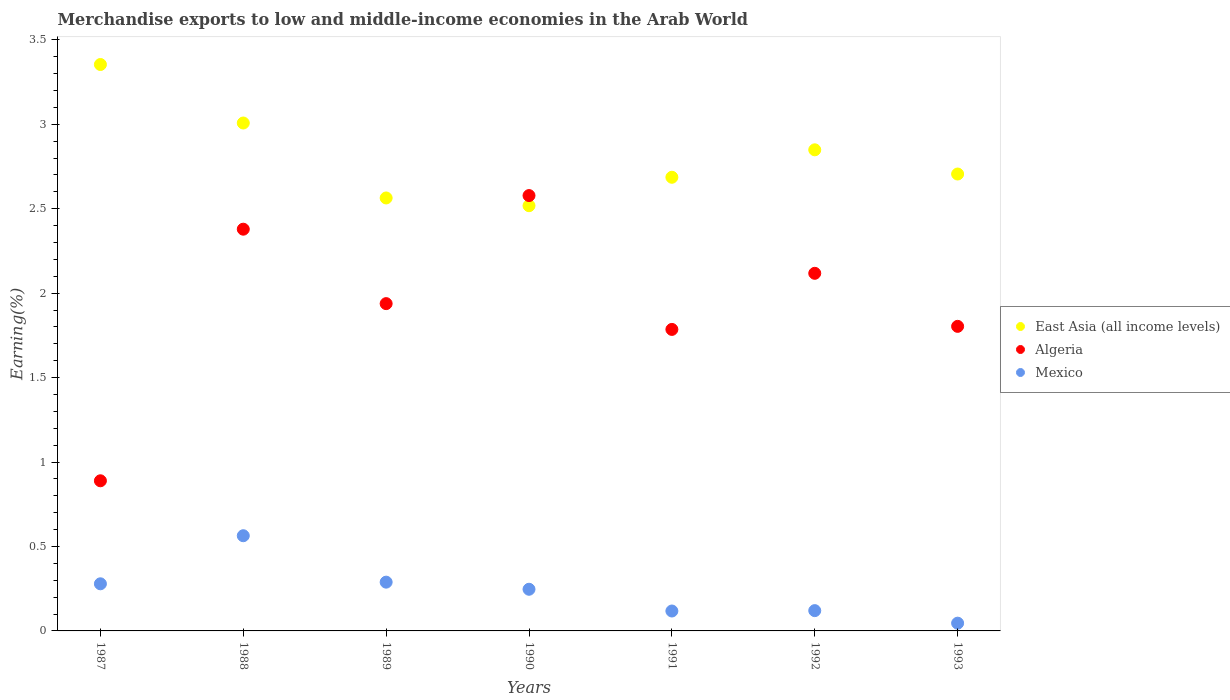How many different coloured dotlines are there?
Keep it short and to the point. 3. What is the percentage of amount earned from merchandise exports in Algeria in 1988?
Keep it short and to the point. 2.38. Across all years, what is the maximum percentage of amount earned from merchandise exports in East Asia (all income levels)?
Your answer should be compact. 3.35. Across all years, what is the minimum percentage of amount earned from merchandise exports in Algeria?
Provide a short and direct response. 0.89. In which year was the percentage of amount earned from merchandise exports in Algeria maximum?
Provide a succinct answer. 1990. In which year was the percentage of amount earned from merchandise exports in East Asia (all income levels) minimum?
Ensure brevity in your answer.  1990. What is the total percentage of amount earned from merchandise exports in Algeria in the graph?
Provide a short and direct response. 13.49. What is the difference between the percentage of amount earned from merchandise exports in East Asia (all income levels) in 1987 and that in 1990?
Your answer should be compact. 0.84. What is the difference between the percentage of amount earned from merchandise exports in Algeria in 1993 and the percentage of amount earned from merchandise exports in Mexico in 1990?
Keep it short and to the point. 1.56. What is the average percentage of amount earned from merchandise exports in Mexico per year?
Provide a short and direct response. 0.24. In the year 1992, what is the difference between the percentage of amount earned from merchandise exports in Algeria and percentage of amount earned from merchandise exports in East Asia (all income levels)?
Your answer should be very brief. -0.73. In how many years, is the percentage of amount earned from merchandise exports in East Asia (all income levels) greater than 1.6 %?
Your answer should be very brief. 7. What is the ratio of the percentage of amount earned from merchandise exports in Algeria in 1991 to that in 1992?
Keep it short and to the point. 0.84. Is the percentage of amount earned from merchandise exports in Mexico in 1988 less than that in 1991?
Your answer should be compact. No. What is the difference between the highest and the second highest percentage of amount earned from merchandise exports in Mexico?
Your answer should be compact. 0.27. What is the difference between the highest and the lowest percentage of amount earned from merchandise exports in Algeria?
Your answer should be compact. 1.69. In how many years, is the percentage of amount earned from merchandise exports in East Asia (all income levels) greater than the average percentage of amount earned from merchandise exports in East Asia (all income levels) taken over all years?
Ensure brevity in your answer.  3. Does the percentage of amount earned from merchandise exports in Mexico monotonically increase over the years?
Give a very brief answer. No. Is the percentage of amount earned from merchandise exports in East Asia (all income levels) strictly greater than the percentage of amount earned from merchandise exports in Algeria over the years?
Offer a very short reply. No. Is the percentage of amount earned from merchandise exports in Algeria strictly less than the percentage of amount earned from merchandise exports in Mexico over the years?
Make the answer very short. No. How many years are there in the graph?
Ensure brevity in your answer.  7. What is the difference between two consecutive major ticks on the Y-axis?
Provide a short and direct response. 0.5. Are the values on the major ticks of Y-axis written in scientific E-notation?
Offer a very short reply. No. How are the legend labels stacked?
Your answer should be compact. Vertical. What is the title of the graph?
Provide a short and direct response. Merchandise exports to low and middle-income economies in the Arab World. Does "Cabo Verde" appear as one of the legend labels in the graph?
Provide a short and direct response. No. What is the label or title of the X-axis?
Provide a succinct answer. Years. What is the label or title of the Y-axis?
Ensure brevity in your answer.  Earning(%). What is the Earning(%) in East Asia (all income levels) in 1987?
Your answer should be compact. 3.35. What is the Earning(%) of Algeria in 1987?
Offer a very short reply. 0.89. What is the Earning(%) in Mexico in 1987?
Give a very brief answer. 0.28. What is the Earning(%) of East Asia (all income levels) in 1988?
Offer a very short reply. 3.01. What is the Earning(%) in Algeria in 1988?
Offer a terse response. 2.38. What is the Earning(%) of Mexico in 1988?
Ensure brevity in your answer.  0.56. What is the Earning(%) of East Asia (all income levels) in 1989?
Your answer should be compact. 2.56. What is the Earning(%) in Algeria in 1989?
Your answer should be very brief. 1.94. What is the Earning(%) in Mexico in 1989?
Provide a succinct answer. 0.29. What is the Earning(%) of East Asia (all income levels) in 1990?
Provide a succinct answer. 2.52. What is the Earning(%) in Algeria in 1990?
Your response must be concise. 2.58. What is the Earning(%) in Mexico in 1990?
Ensure brevity in your answer.  0.25. What is the Earning(%) in East Asia (all income levels) in 1991?
Give a very brief answer. 2.69. What is the Earning(%) in Algeria in 1991?
Your answer should be very brief. 1.79. What is the Earning(%) of Mexico in 1991?
Provide a short and direct response. 0.12. What is the Earning(%) of East Asia (all income levels) in 1992?
Provide a short and direct response. 2.85. What is the Earning(%) of Algeria in 1992?
Make the answer very short. 2.12. What is the Earning(%) of Mexico in 1992?
Give a very brief answer. 0.12. What is the Earning(%) of East Asia (all income levels) in 1993?
Your response must be concise. 2.71. What is the Earning(%) of Algeria in 1993?
Ensure brevity in your answer.  1.8. What is the Earning(%) in Mexico in 1993?
Give a very brief answer. 0.05. Across all years, what is the maximum Earning(%) in East Asia (all income levels)?
Make the answer very short. 3.35. Across all years, what is the maximum Earning(%) of Algeria?
Keep it short and to the point. 2.58. Across all years, what is the maximum Earning(%) in Mexico?
Offer a terse response. 0.56. Across all years, what is the minimum Earning(%) of East Asia (all income levels)?
Ensure brevity in your answer.  2.52. Across all years, what is the minimum Earning(%) in Algeria?
Your answer should be compact. 0.89. Across all years, what is the minimum Earning(%) of Mexico?
Provide a short and direct response. 0.05. What is the total Earning(%) of East Asia (all income levels) in the graph?
Your answer should be very brief. 19.68. What is the total Earning(%) in Algeria in the graph?
Your response must be concise. 13.49. What is the total Earning(%) in Mexico in the graph?
Ensure brevity in your answer.  1.66. What is the difference between the Earning(%) in East Asia (all income levels) in 1987 and that in 1988?
Provide a succinct answer. 0.35. What is the difference between the Earning(%) of Algeria in 1987 and that in 1988?
Offer a terse response. -1.49. What is the difference between the Earning(%) in Mexico in 1987 and that in 1988?
Provide a succinct answer. -0.28. What is the difference between the Earning(%) in East Asia (all income levels) in 1987 and that in 1989?
Provide a short and direct response. 0.79. What is the difference between the Earning(%) of Algeria in 1987 and that in 1989?
Offer a terse response. -1.05. What is the difference between the Earning(%) of Mexico in 1987 and that in 1989?
Provide a succinct answer. -0.01. What is the difference between the Earning(%) of East Asia (all income levels) in 1987 and that in 1990?
Your response must be concise. 0.84. What is the difference between the Earning(%) in Algeria in 1987 and that in 1990?
Ensure brevity in your answer.  -1.69. What is the difference between the Earning(%) of Mexico in 1987 and that in 1990?
Ensure brevity in your answer.  0.03. What is the difference between the Earning(%) of East Asia (all income levels) in 1987 and that in 1991?
Your response must be concise. 0.67. What is the difference between the Earning(%) of Algeria in 1987 and that in 1991?
Keep it short and to the point. -0.9. What is the difference between the Earning(%) of Mexico in 1987 and that in 1991?
Offer a terse response. 0.16. What is the difference between the Earning(%) of East Asia (all income levels) in 1987 and that in 1992?
Offer a very short reply. 0.51. What is the difference between the Earning(%) in Algeria in 1987 and that in 1992?
Offer a terse response. -1.23. What is the difference between the Earning(%) of Mexico in 1987 and that in 1992?
Offer a terse response. 0.16. What is the difference between the Earning(%) of East Asia (all income levels) in 1987 and that in 1993?
Your answer should be compact. 0.65. What is the difference between the Earning(%) in Algeria in 1987 and that in 1993?
Your answer should be very brief. -0.91. What is the difference between the Earning(%) in Mexico in 1987 and that in 1993?
Your response must be concise. 0.23. What is the difference between the Earning(%) of East Asia (all income levels) in 1988 and that in 1989?
Offer a terse response. 0.44. What is the difference between the Earning(%) of Algeria in 1988 and that in 1989?
Make the answer very short. 0.44. What is the difference between the Earning(%) in Mexico in 1988 and that in 1989?
Ensure brevity in your answer.  0.27. What is the difference between the Earning(%) in East Asia (all income levels) in 1988 and that in 1990?
Give a very brief answer. 0.49. What is the difference between the Earning(%) of Algeria in 1988 and that in 1990?
Ensure brevity in your answer.  -0.2. What is the difference between the Earning(%) in Mexico in 1988 and that in 1990?
Keep it short and to the point. 0.32. What is the difference between the Earning(%) of East Asia (all income levels) in 1988 and that in 1991?
Provide a succinct answer. 0.32. What is the difference between the Earning(%) in Algeria in 1988 and that in 1991?
Provide a succinct answer. 0.59. What is the difference between the Earning(%) in Mexico in 1988 and that in 1991?
Provide a succinct answer. 0.45. What is the difference between the Earning(%) of East Asia (all income levels) in 1988 and that in 1992?
Your response must be concise. 0.16. What is the difference between the Earning(%) of Algeria in 1988 and that in 1992?
Your response must be concise. 0.26. What is the difference between the Earning(%) of Mexico in 1988 and that in 1992?
Make the answer very short. 0.44. What is the difference between the Earning(%) of East Asia (all income levels) in 1988 and that in 1993?
Provide a short and direct response. 0.3. What is the difference between the Earning(%) of Algeria in 1988 and that in 1993?
Ensure brevity in your answer.  0.58. What is the difference between the Earning(%) of Mexico in 1988 and that in 1993?
Your answer should be compact. 0.52. What is the difference between the Earning(%) in East Asia (all income levels) in 1989 and that in 1990?
Provide a succinct answer. 0.05. What is the difference between the Earning(%) in Algeria in 1989 and that in 1990?
Keep it short and to the point. -0.64. What is the difference between the Earning(%) of Mexico in 1989 and that in 1990?
Give a very brief answer. 0.04. What is the difference between the Earning(%) of East Asia (all income levels) in 1989 and that in 1991?
Ensure brevity in your answer.  -0.12. What is the difference between the Earning(%) of Algeria in 1989 and that in 1991?
Provide a short and direct response. 0.15. What is the difference between the Earning(%) in Mexico in 1989 and that in 1991?
Make the answer very short. 0.17. What is the difference between the Earning(%) in East Asia (all income levels) in 1989 and that in 1992?
Provide a short and direct response. -0.28. What is the difference between the Earning(%) of Algeria in 1989 and that in 1992?
Keep it short and to the point. -0.18. What is the difference between the Earning(%) in Mexico in 1989 and that in 1992?
Your answer should be very brief. 0.17. What is the difference between the Earning(%) in East Asia (all income levels) in 1989 and that in 1993?
Provide a succinct answer. -0.14. What is the difference between the Earning(%) in Algeria in 1989 and that in 1993?
Provide a short and direct response. 0.13. What is the difference between the Earning(%) of Mexico in 1989 and that in 1993?
Keep it short and to the point. 0.24. What is the difference between the Earning(%) of East Asia (all income levels) in 1990 and that in 1991?
Provide a short and direct response. -0.17. What is the difference between the Earning(%) of Algeria in 1990 and that in 1991?
Your answer should be compact. 0.79. What is the difference between the Earning(%) of Mexico in 1990 and that in 1991?
Provide a short and direct response. 0.13. What is the difference between the Earning(%) of East Asia (all income levels) in 1990 and that in 1992?
Your answer should be very brief. -0.33. What is the difference between the Earning(%) in Algeria in 1990 and that in 1992?
Your answer should be compact. 0.46. What is the difference between the Earning(%) of Mexico in 1990 and that in 1992?
Give a very brief answer. 0.13. What is the difference between the Earning(%) in East Asia (all income levels) in 1990 and that in 1993?
Provide a succinct answer. -0.19. What is the difference between the Earning(%) of Algeria in 1990 and that in 1993?
Ensure brevity in your answer.  0.77. What is the difference between the Earning(%) of Mexico in 1990 and that in 1993?
Make the answer very short. 0.2. What is the difference between the Earning(%) of East Asia (all income levels) in 1991 and that in 1992?
Make the answer very short. -0.16. What is the difference between the Earning(%) in Algeria in 1991 and that in 1992?
Offer a very short reply. -0.33. What is the difference between the Earning(%) in Mexico in 1991 and that in 1992?
Offer a terse response. -0. What is the difference between the Earning(%) of East Asia (all income levels) in 1991 and that in 1993?
Keep it short and to the point. -0.02. What is the difference between the Earning(%) in Algeria in 1991 and that in 1993?
Offer a very short reply. -0.02. What is the difference between the Earning(%) of Mexico in 1991 and that in 1993?
Provide a succinct answer. 0.07. What is the difference between the Earning(%) in East Asia (all income levels) in 1992 and that in 1993?
Your answer should be compact. 0.14. What is the difference between the Earning(%) of Algeria in 1992 and that in 1993?
Keep it short and to the point. 0.31. What is the difference between the Earning(%) in Mexico in 1992 and that in 1993?
Provide a short and direct response. 0.07. What is the difference between the Earning(%) of East Asia (all income levels) in 1987 and the Earning(%) of Algeria in 1988?
Offer a terse response. 0.97. What is the difference between the Earning(%) of East Asia (all income levels) in 1987 and the Earning(%) of Mexico in 1988?
Ensure brevity in your answer.  2.79. What is the difference between the Earning(%) of Algeria in 1987 and the Earning(%) of Mexico in 1988?
Keep it short and to the point. 0.33. What is the difference between the Earning(%) in East Asia (all income levels) in 1987 and the Earning(%) in Algeria in 1989?
Provide a succinct answer. 1.42. What is the difference between the Earning(%) in East Asia (all income levels) in 1987 and the Earning(%) in Mexico in 1989?
Keep it short and to the point. 3.06. What is the difference between the Earning(%) in Algeria in 1987 and the Earning(%) in Mexico in 1989?
Make the answer very short. 0.6. What is the difference between the Earning(%) of East Asia (all income levels) in 1987 and the Earning(%) of Algeria in 1990?
Make the answer very short. 0.78. What is the difference between the Earning(%) of East Asia (all income levels) in 1987 and the Earning(%) of Mexico in 1990?
Provide a short and direct response. 3.11. What is the difference between the Earning(%) of Algeria in 1987 and the Earning(%) of Mexico in 1990?
Provide a succinct answer. 0.64. What is the difference between the Earning(%) of East Asia (all income levels) in 1987 and the Earning(%) of Algeria in 1991?
Offer a very short reply. 1.57. What is the difference between the Earning(%) in East Asia (all income levels) in 1987 and the Earning(%) in Mexico in 1991?
Keep it short and to the point. 3.24. What is the difference between the Earning(%) in Algeria in 1987 and the Earning(%) in Mexico in 1991?
Give a very brief answer. 0.77. What is the difference between the Earning(%) of East Asia (all income levels) in 1987 and the Earning(%) of Algeria in 1992?
Your answer should be compact. 1.24. What is the difference between the Earning(%) in East Asia (all income levels) in 1987 and the Earning(%) in Mexico in 1992?
Your answer should be compact. 3.23. What is the difference between the Earning(%) in Algeria in 1987 and the Earning(%) in Mexico in 1992?
Provide a short and direct response. 0.77. What is the difference between the Earning(%) of East Asia (all income levels) in 1987 and the Earning(%) of Algeria in 1993?
Give a very brief answer. 1.55. What is the difference between the Earning(%) of East Asia (all income levels) in 1987 and the Earning(%) of Mexico in 1993?
Offer a terse response. 3.31. What is the difference between the Earning(%) of Algeria in 1987 and the Earning(%) of Mexico in 1993?
Offer a very short reply. 0.84. What is the difference between the Earning(%) in East Asia (all income levels) in 1988 and the Earning(%) in Algeria in 1989?
Keep it short and to the point. 1.07. What is the difference between the Earning(%) in East Asia (all income levels) in 1988 and the Earning(%) in Mexico in 1989?
Offer a terse response. 2.72. What is the difference between the Earning(%) in Algeria in 1988 and the Earning(%) in Mexico in 1989?
Provide a succinct answer. 2.09. What is the difference between the Earning(%) of East Asia (all income levels) in 1988 and the Earning(%) of Algeria in 1990?
Make the answer very short. 0.43. What is the difference between the Earning(%) of East Asia (all income levels) in 1988 and the Earning(%) of Mexico in 1990?
Your answer should be compact. 2.76. What is the difference between the Earning(%) in Algeria in 1988 and the Earning(%) in Mexico in 1990?
Your answer should be very brief. 2.13. What is the difference between the Earning(%) of East Asia (all income levels) in 1988 and the Earning(%) of Algeria in 1991?
Ensure brevity in your answer.  1.22. What is the difference between the Earning(%) in East Asia (all income levels) in 1988 and the Earning(%) in Mexico in 1991?
Make the answer very short. 2.89. What is the difference between the Earning(%) of Algeria in 1988 and the Earning(%) of Mexico in 1991?
Offer a very short reply. 2.26. What is the difference between the Earning(%) of East Asia (all income levels) in 1988 and the Earning(%) of Algeria in 1992?
Offer a terse response. 0.89. What is the difference between the Earning(%) of East Asia (all income levels) in 1988 and the Earning(%) of Mexico in 1992?
Make the answer very short. 2.89. What is the difference between the Earning(%) in Algeria in 1988 and the Earning(%) in Mexico in 1992?
Keep it short and to the point. 2.26. What is the difference between the Earning(%) in East Asia (all income levels) in 1988 and the Earning(%) in Algeria in 1993?
Offer a very short reply. 1.2. What is the difference between the Earning(%) in East Asia (all income levels) in 1988 and the Earning(%) in Mexico in 1993?
Make the answer very short. 2.96. What is the difference between the Earning(%) of Algeria in 1988 and the Earning(%) of Mexico in 1993?
Provide a short and direct response. 2.33. What is the difference between the Earning(%) of East Asia (all income levels) in 1989 and the Earning(%) of Algeria in 1990?
Your response must be concise. -0.01. What is the difference between the Earning(%) in East Asia (all income levels) in 1989 and the Earning(%) in Mexico in 1990?
Your answer should be compact. 2.32. What is the difference between the Earning(%) of Algeria in 1989 and the Earning(%) of Mexico in 1990?
Make the answer very short. 1.69. What is the difference between the Earning(%) in East Asia (all income levels) in 1989 and the Earning(%) in Algeria in 1991?
Give a very brief answer. 0.78. What is the difference between the Earning(%) of East Asia (all income levels) in 1989 and the Earning(%) of Mexico in 1991?
Offer a very short reply. 2.45. What is the difference between the Earning(%) in Algeria in 1989 and the Earning(%) in Mexico in 1991?
Provide a succinct answer. 1.82. What is the difference between the Earning(%) in East Asia (all income levels) in 1989 and the Earning(%) in Algeria in 1992?
Your response must be concise. 0.45. What is the difference between the Earning(%) of East Asia (all income levels) in 1989 and the Earning(%) of Mexico in 1992?
Ensure brevity in your answer.  2.44. What is the difference between the Earning(%) in Algeria in 1989 and the Earning(%) in Mexico in 1992?
Your answer should be compact. 1.82. What is the difference between the Earning(%) in East Asia (all income levels) in 1989 and the Earning(%) in Algeria in 1993?
Provide a succinct answer. 0.76. What is the difference between the Earning(%) in East Asia (all income levels) in 1989 and the Earning(%) in Mexico in 1993?
Your response must be concise. 2.52. What is the difference between the Earning(%) in Algeria in 1989 and the Earning(%) in Mexico in 1993?
Give a very brief answer. 1.89. What is the difference between the Earning(%) of East Asia (all income levels) in 1990 and the Earning(%) of Algeria in 1991?
Provide a short and direct response. 0.73. What is the difference between the Earning(%) of East Asia (all income levels) in 1990 and the Earning(%) of Mexico in 1991?
Your response must be concise. 2.4. What is the difference between the Earning(%) of Algeria in 1990 and the Earning(%) of Mexico in 1991?
Provide a short and direct response. 2.46. What is the difference between the Earning(%) in East Asia (all income levels) in 1990 and the Earning(%) in Algeria in 1992?
Offer a very short reply. 0.4. What is the difference between the Earning(%) in East Asia (all income levels) in 1990 and the Earning(%) in Mexico in 1992?
Your answer should be compact. 2.4. What is the difference between the Earning(%) of Algeria in 1990 and the Earning(%) of Mexico in 1992?
Your answer should be very brief. 2.46. What is the difference between the Earning(%) in East Asia (all income levels) in 1990 and the Earning(%) in Algeria in 1993?
Your response must be concise. 0.71. What is the difference between the Earning(%) of East Asia (all income levels) in 1990 and the Earning(%) of Mexico in 1993?
Ensure brevity in your answer.  2.47. What is the difference between the Earning(%) of Algeria in 1990 and the Earning(%) of Mexico in 1993?
Your answer should be very brief. 2.53. What is the difference between the Earning(%) in East Asia (all income levels) in 1991 and the Earning(%) in Algeria in 1992?
Give a very brief answer. 0.57. What is the difference between the Earning(%) of East Asia (all income levels) in 1991 and the Earning(%) of Mexico in 1992?
Your response must be concise. 2.57. What is the difference between the Earning(%) in Algeria in 1991 and the Earning(%) in Mexico in 1992?
Your response must be concise. 1.67. What is the difference between the Earning(%) of East Asia (all income levels) in 1991 and the Earning(%) of Algeria in 1993?
Offer a terse response. 0.88. What is the difference between the Earning(%) in East Asia (all income levels) in 1991 and the Earning(%) in Mexico in 1993?
Keep it short and to the point. 2.64. What is the difference between the Earning(%) in Algeria in 1991 and the Earning(%) in Mexico in 1993?
Your answer should be very brief. 1.74. What is the difference between the Earning(%) in East Asia (all income levels) in 1992 and the Earning(%) in Algeria in 1993?
Ensure brevity in your answer.  1.05. What is the difference between the Earning(%) in East Asia (all income levels) in 1992 and the Earning(%) in Mexico in 1993?
Offer a terse response. 2.8. What is the difference between the Earning(%) in Algeria in 1992 and the Earning(%) in Mexico in 1993?
Make the answer very short. 2.07. What is the average Earning(%) of East Asia (all income levels) per year?
Provide a succinct answer. 2.81. What is the average Earning(%) in Algeria per year?
Offer a very short reply. 1.93. What is the average Earning(%) of Mexico per year?
Provide a succinct answer. 0.24. In the year 1987, what is the difference between the Earning(%) of East Asia (all income levels) and Earning(%) of Algeria?
Make the answer very short. 2.46. In the year 1987, what is the difference between the Earning(%) in East Asia (all income levels) and Earning(%) in Mexico?
Give a very brief answer. 3.07. In the year 1987, what is the difference between the Earning(%) in Algeria and Earning(%) in Mexico?
Ensure brevity in your answer.  0.61. In the year 1988, what is the difference between the Earning(%) of East Asia (all income levels) and Earning(%) of Algeria?
Offer a terse response. 0.63. In the year 1988, what is the difference between the Earning(%) of East Asia (all income levels) and Earning(%) of Mexico?
Give a very brief answer. 2.44. In the year 1988, what is the difference between the Earning(%) of Algeria and Earning(%) of Mexico?
Offer a terse response. 1.81. In the year 1989, what is the difference between the Earning(%) in East Asia (all income levels) and Earning(%) in Algeria?
Keep it short and to the point. 0.63. In the year 1989, what is the difference between the Earning(%) of East Asia (all income levels) and Earning(%) of Mexico?
Keep it short and to the point. 2.27. In the year 1989, what is the difference between the Earning(%) of Algeria and Earning(%) of Mexico?
Make the answer very short. 1.65. In the year 1990, what is the difference between the Earning(%) in East Asia (all income levels) and Earning(%) in Algeria?
Provide a succinct answer. -0.06. In the year 1990, what is the difference between the Earning(%) of East Asia (all income levels) and Earning(%) of Mexico?
Your answer should be very brief. 2.27. In the year 1990, what is the difference between the Earning(%) in Algeria and Earning(%) in Mexico?
Offer a very short reply. 2.33. In the year 1991, what is the difference between the Earning(%) of East Asia (all income levels) and Earning(%) of Algeria?
Give a very brief answer. 0.9. In the year 1991, what is the difference between the Earning(%) of East Asia (all income levels) and Earning(%) of Mexico?
Give a very brief answer. 2.57. In the year 1991, what is the difference between the Earning(%) of Algeria and Earning(%) of Mexico?
Offer a very short reply. 1.67. In the year 1992, what is the difference between the Earning(%) of East Asia (all income levels) and Earning(%) of Algeria?
Your answer should be compact. 0.73. In the year 1992, what is the difference between the Earning(%) of East Asia (all income levels) and Earning(%) of Mexico?
Offer a terse response. 2.73. In the year 1992, what is the difference between the Earning(%) of Algeria and Earning(%) of Mexico?
Ensure brevity in your answer.  2. In the year 1993, what is the difference between the Earning(%) in East Asia (all income levels) and Earning(%) in Algeria?
Offer a very short reply. 0.9. In the year 1993, what is the difference between the Earning(%) of East Asia (all income levels) and Earning(%) of Mexico?
Your response must be concise. 2.66. In the year 1993, what is the difference between the Earning(%) in Algeria and Earning(%) in Mexico?
Keep it short and to the point. 1.76. What is the ratio of the Earning(%) in East Asia (all income levels) in 1987 to that in 1988?
Ensure brevity in your answer.  1.12. What is the ratio of the Earning(%) of Algeria in 1987 to that in 1988?
Ensure brevity in your answer.  0.37. What is the ratio of the Earning(%) of Mexico in 1987 to that in 1988?
Offer a terse response. 0.49. What is the ratio of the Earning(%) in East Asia (all income levels) in 1987 to that in 1989?
Make the answer very short. 1.31. What is the ratio of the Earning(%) of Algeria in 1987 to that in 1989?
Your answer should be very brief. 0.46. What is the ratio of the Earning(%) in Mexico in 1987 to that in 1989?
Give a very brief answer. 0.97. What is the ratio of the Earning(%) in East Asia (all income levels) in 1987 to that in 1990?
Your answer should be very brief. 1.33. What is the ratio of the Earning(%) of Algeria in 1987 to that in 1990?
Provide a short and direct response. 0.34. What is the ratio of the Earning(%) in Mexico in 1987 to that in 1990?
Your answer should be very brief. 1.13. What is the ratio of the Earning(%) of East Asia (all income levels) in 1987 to that in 1991?
Make the answer very short. 1.25. What is the ratio of the Earning(%) in Algeria in 1987 to that in 1991?
Keep it short and to the point. 0.5. What is the ratio of the Earning(%) of Mexico in 1987 to that in 1991?
Provide a succinct answer. 2.37. What is the ratio of the Earning(%) of East Asia (all income levels) in 1987 to that in 1992?
Offer a very short reply. 1.18. What is the ratio of the Earning(%) of Algeria in 1987 to that in 1992?
Keep it short and to the point. 0.42. What is the ratio of the Earning(%) in Mexico in 1987 to that in 1992?
Keep it short and to the point. 2.32. What is the ratio of the Earning(%) in East Asia (all income levels) in 1987 to that in 1993?
Provide a short and direct response. 1.24. What is the ratio of the Earning(%) in Algeria in 1987 to that in 1993?
Provide a short and direct response. 0.49. What is the ratio of the Earning(%) in Mexico in 1987 to that in 1993?
Your answer should be very brief. 6.08. What is the ratio of the Earning(%) in East Asia (all income levels) in 1988 to that in 1989?
Provide a short and direct response. 1.17. What is the ratio of the Earning(%) in Algeria in 1988 to that in 1989?
Provide a short and direct response. 1.23. What is the ratio of the Earning(%) of Mexico in 1988 to that in 1989?
Provide a short and direct response. 1.95. What is the ratio of the Earning(%) of East Asia (all income levels) in 1988 to that in 1990?
Make the answer very short. 1.19. What is the ratio of the Earning(%) of Algeria in 1988 to that in 1990?
Offer a terse response. 0.92. What is the ratio of the Earning(%) of Mexico in 1988 to that in 1990?
Give a very brief answer. 2.28. What is the ratio of the Earning(%) in East Asia (all income levels) in 1988 to that in 1991?
Offer a terse response. 1.12. What is the ratio of the Earning(%) of Algeria in 1988 to that in 1991?
Provide a succinct answer. 1.33. What is the ratio of the Earning(%) of Mexico in 1988 to that in 1991?
Offer a terse response. 4.78. What is the ratio of the Earning(%) in East Asia (all income levels) in 1988 to that in 1992?
Provide a succinct answer. 1.06. What is the ratio of the Earning(%) in Algeria in 1988 to that in 1992?
Your response must be concise. 1.12. What is the ratio of the Earning(%) of Mexico in 1988 to that in 1992?
Provide a short and direct response. 4.69. What is the ratio of the Earning(%) of East Asia (all income levels) in 1988 to that in 1993?
Provide a short and direct response. 1.11. What is the ratio of the Earning(%) in Algeria in 1988 to that in 1993?
Your answer should be very brief. 1.32. What is the ratio of the Earning(%) in Mexico in 1988 to that in 1993?
Keep it short and to the point. 12.28. What is the ratio of the Earning(%) in East Asia (all income levels) in 1989 to that in 1990?
Provide a short and direct response. 1.02. What is the ratio of the Earning(%) of Algeria in 1989 to that in 1990?
Provide a short and direct response. 0.75. What is the ratio of the Earning(%) in Mexico in 1989 to that in 1990?
Your answer should be compact. 1.17. What is the ratio of the Earning(%) of East Asia (all income levels) in 1989 to that in 1991?
Your response must be concise. 0.95. What is the ratio of the Earning(%) in Algeria in 1989 to that in 1991?
Your answer should be very brief. 1.09. What is the ratio of the Earning(%) in Mexico in 1989 to that in 1991?
Offer a terse response. 2.45. What is the ratio of the Earning(%) of East Asia (all income levels) in 1989 to that in 1992?
Make the answer very short. 0.9. What is the ratio of the Earning(%) of Algeria in 1989 to that in 1992?
Your answer should be very brief. 0.92. What is the ratio of the Earning(%) in Mexico in 1989 to that in 1992?
Make the answer very short. 2.4. What is the ratio of the Earning(%) in East Asia (all income levels) in 1989 to that in 1993?
Give a very brief answer. 0.95. What is the ratio of the Earning(%) in Algeria in 1989 to that in 1993?
Keep it short and to the point. 1.07. What is the ratio of the Earning(%) of Mexico in 1989 to that in 1993?
Offer a very short reply. 6.29. What is the ratio of the Earning(%) in East Asia (all income levels) in 1990 to that in 1991?
Provide a short and direct response. 0.94. What is the ratio of the Earning(%) in Algeria in 1990 to that in 1991?
Provide a short and direct response. 1.44. What is the ratio of the Earning(%) of Mexico in 1990 to that in 1991?
Provide a succinct answer. 2.09. What is the ratio of the Earning(%) in East Asia (all income levels) in 1990 to that in 1992?
Your answer should be very brief. 0.88. What is the ratio of the Earning(%) in Algeria in 1990 to that in 1992?
Keep it short and to the point. 1.22. What is the ratio of the Earning(%) of Mexico in 1990 to that in 1992?
Keep it short and to the point. 2.05. What is the ratio of the Earning(%) in East Asia (all income levels) in 1990 to that in 1993?
Offer a terse response. 0.93. What is the ratio of the Earning(%) of Algeria in 1990 to that in 1993?
Offer a terse response. 1.43. What is the ratio of the Earning(%) in Mexico in 1990 to that in 1993?
Provide a succinct answer. 5.37. What is the ratio of the Earning(%) of East Asia (all income levels) in 1991 to that in 1992?
Offer a very short reply. 0.94. What is the ratio of the Earning(%) in Algeria in 1991 to that in 1992?
Make the answer very short. 0.84. What is the ratio of the Earning(%) in Mexico in 1991 to that in 1992?
Provide a short and direct response. 0.98. What is the ratio of the Earning(%) in East Asia (all income levels) in 1991 to that in 1993?
Provide a short and direct response. 0.99. What is the ratio of the Earning(%) of Algeria in 1991 to that in 1993?
Give a very brief answer. 0.99. What is the ratio of the Earning(%) in Mexico in 1991 to that in 1993?
Your response must be concise. 2.57. What is the ratio of the Earning(%) of East Asia (all income levels) in 1992 to that in 1993?
Offer a terse response. 1.05. What is the ratio of the Earning(%) of Algeria in 1992 to that in 1993?
Keep it short and to the point. 1.17. What is the ratio of the Earning(%) of Mexico in 1992 to that in 1993?
Provide a succinct answer. 2.62. What is the difference between the highest and the second highest Earning(%) in East Asia (all income levels)?
Make the answer very short. 0.35. What is the difference between the highest and the second highest Earning(%) in Algeria?
Keep it short and to the point. 0.2. What is the difference between the highest and the second highest Earning(%) of Mexico?
Keep it short and to the point. 0.27. What is the difference between the highest and the lowest Earning(%) of East Asia (all income levels)?
Ensure brevity in your answer.  0.84. What is the difference between the highest and the lowest Earning(%) of Algeria?
Offer a terse response. 1.69. What is the difference between the highest and the lowest Earning(%) in Mexico?
Your response must be concise. 0.52. 